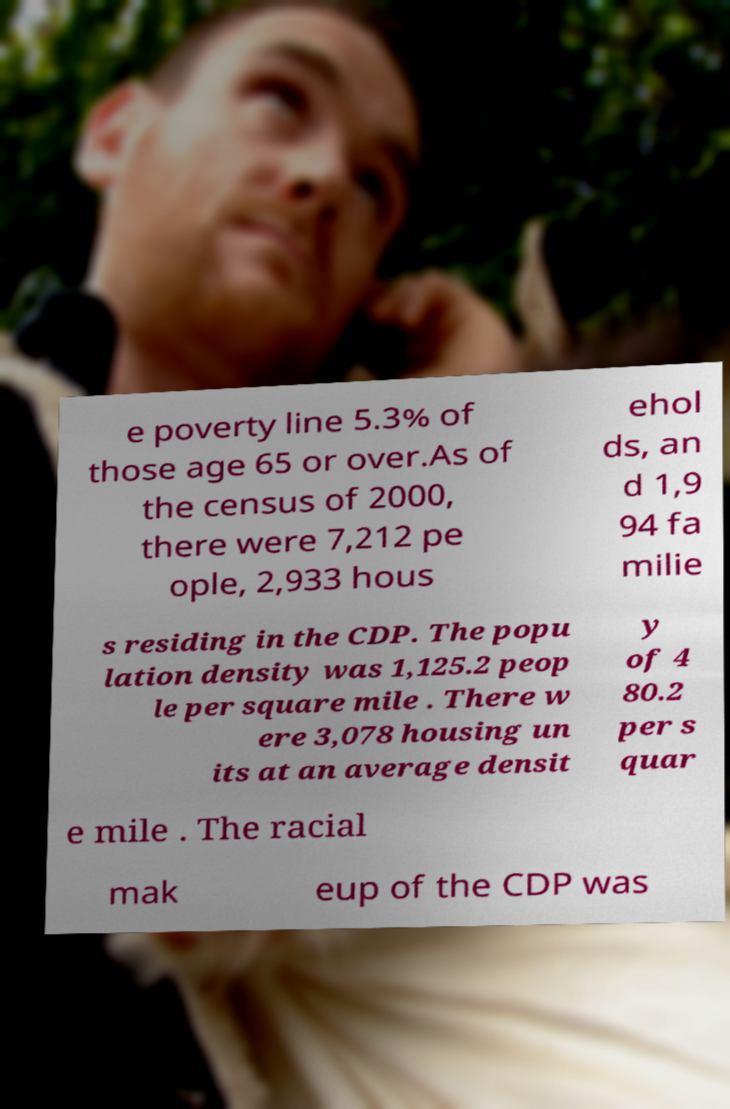Could you assist in decoding the text presented in this image and type it out clearly? e poverty line 5.3% of those age 65 or over.As of the census of 2000, there were 7,212 pe ople, 2,933 hous ehol ds, an d 1,9 94 fa milie s residing in the CDP. The popu lation density was 1,125.2 peop le per square mile . There w ere 3,078 housing un its at an average densit y of 4 80.2 per s quar e mile . The racial mak eup of the CDP was 